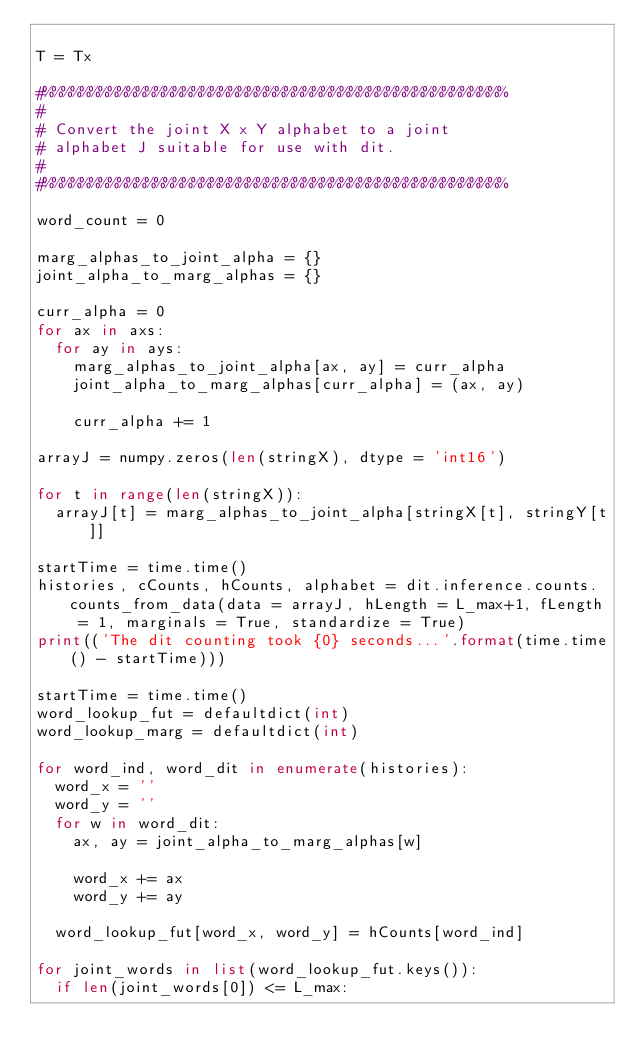Convert code to text. <code><loc_0><loc_0><loc_500><loc_500><_Python_>
T = Tx

#%%%%%%%%%%%%%%%%%%%%%%%%%%%%%%%%%%%%%%%%%%%%%%%%%%
#
# Convert the joint X x Y alphabet to a joint
# alphabet J suitable for use with dit.
#
#%%%%%%%%%%%%%%%%%%%%%%%%%%%%%%%%%%%%%%%%%%%%%%%%%%

word_count = 0

marg_alphas_to_joint_alpha = {}
joint_alpha_to_marg_alphas = {}

curr_alpha = 0
for ax in axs:
	for ay in ays:
		marg_alphas_to_joint_alpha[ax, ay] = curr_alpha
		joint_alpha_to_marg_alphas[curr_alpha] = (ax, ay)

		curr_alpha += 1

arrayJ = numpy.zeros(len(stringX), dtype = 'int16')

for t in range(len(stringX)):
	arrayJ[t] = marg_alphas_to_joint_alpha[stringX[t], stringY[t]]

startTime = time.time()
histories, cCounts, hCounts, alphabet = dit.inference.counts.counts_from_data(data = arrayJ, hLength = L_max+1, fLength = 1, marginals = True, standardize = True)
print(('The dit counting took {0} seconds...'.format(time.time() - startTime)))

startTime = time.time()
word_lookup_fut = defaultdict(int)
word_lookup_marg = defaultdict(int)

for word_ind, word_dit in enumerate(histories):
	word_x = ''
	word_y = ''
	for w in word_dit:
		ax, ay = joint_alpha_to_marg_alphas[w]

		word_x += ax
		word_y += ay

	word_lookup_fut[word_x, word_y] = hCounts[word_ind]

for joint_words in list(word_lookup_fut.keys()):
	if len(joint_words[0]) <= L_max:</code> 